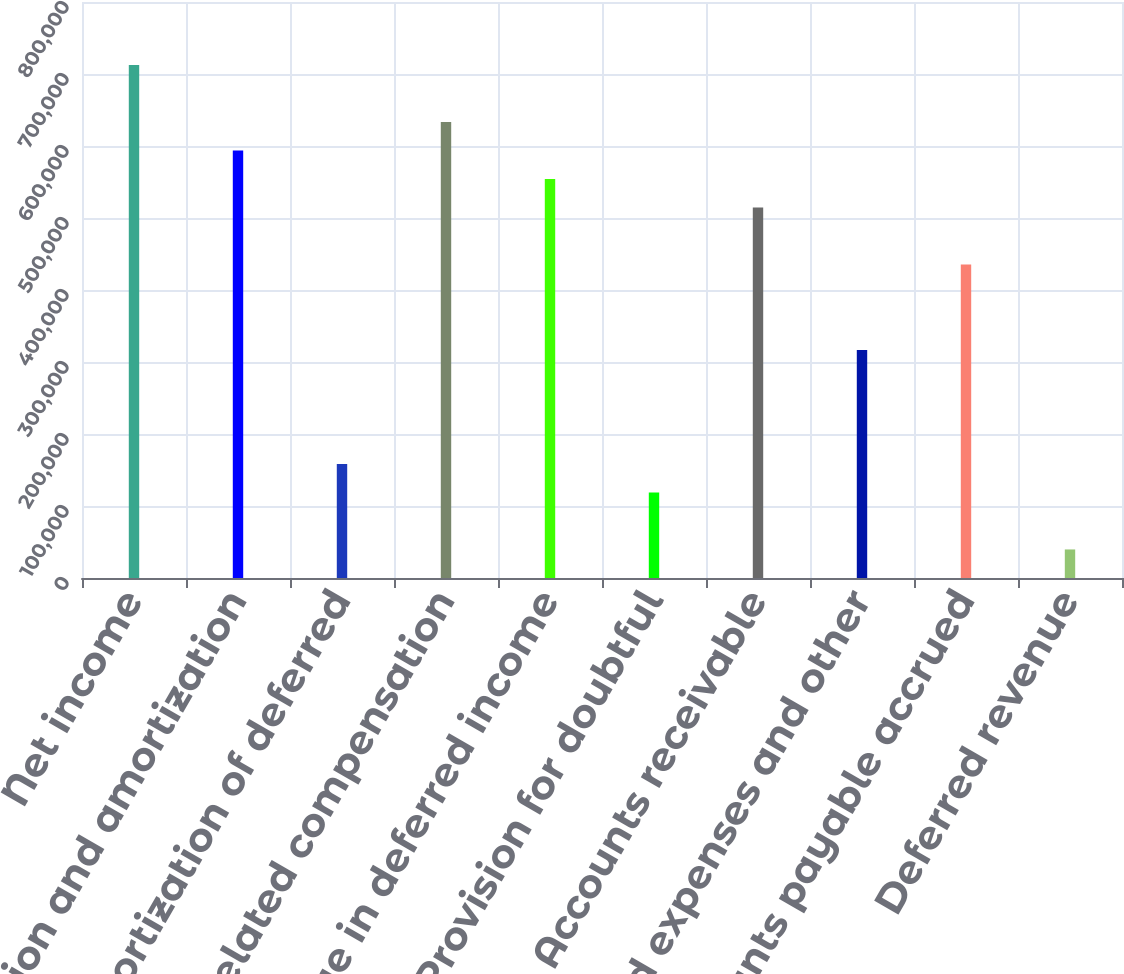<chart> <loc_0><loc_0><loc_500><loc_500><bar_chart><fcel>Net income<fcel>Depreciation and amortization<fcel>Amortization of deferred<fcel>Stock-related compensation<fcel>Change in deferred income<fcel>Provision for doubtful<fcel>Accounts receivable<fcel>Prepaid expenses and other<fcel>Accounts payable accrued<fcel>Deferred revenue<nl><fcel>712515<fcel>593774<fcel>158388<fcel>633354<fcel>554193<fcel>118808<fcel>514612<fcel>316710<fcel>435452<fcel>39646.5<nl></chart> 